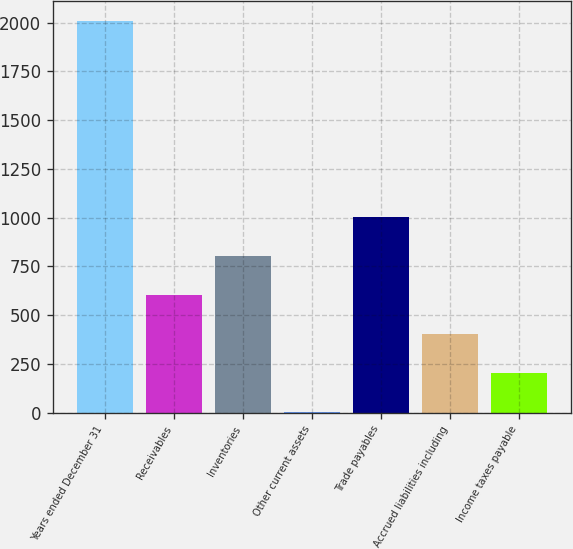<chart> <loc_0><loc_0><loc_500><loc_500><bar_chart><fcel>Years ended December 31<fcel>Receivables<fcel>Inventories<fcel>Other current assets<fcel>Trade payables<fcel>Accrued liabilities including<fcel>Income taxes payable<nl><fcel>2009<fcel>603.4<fcel>804.2<fcel>1<fcel>1005<fcel>402.6<fcel>201.8<nl></chart> 